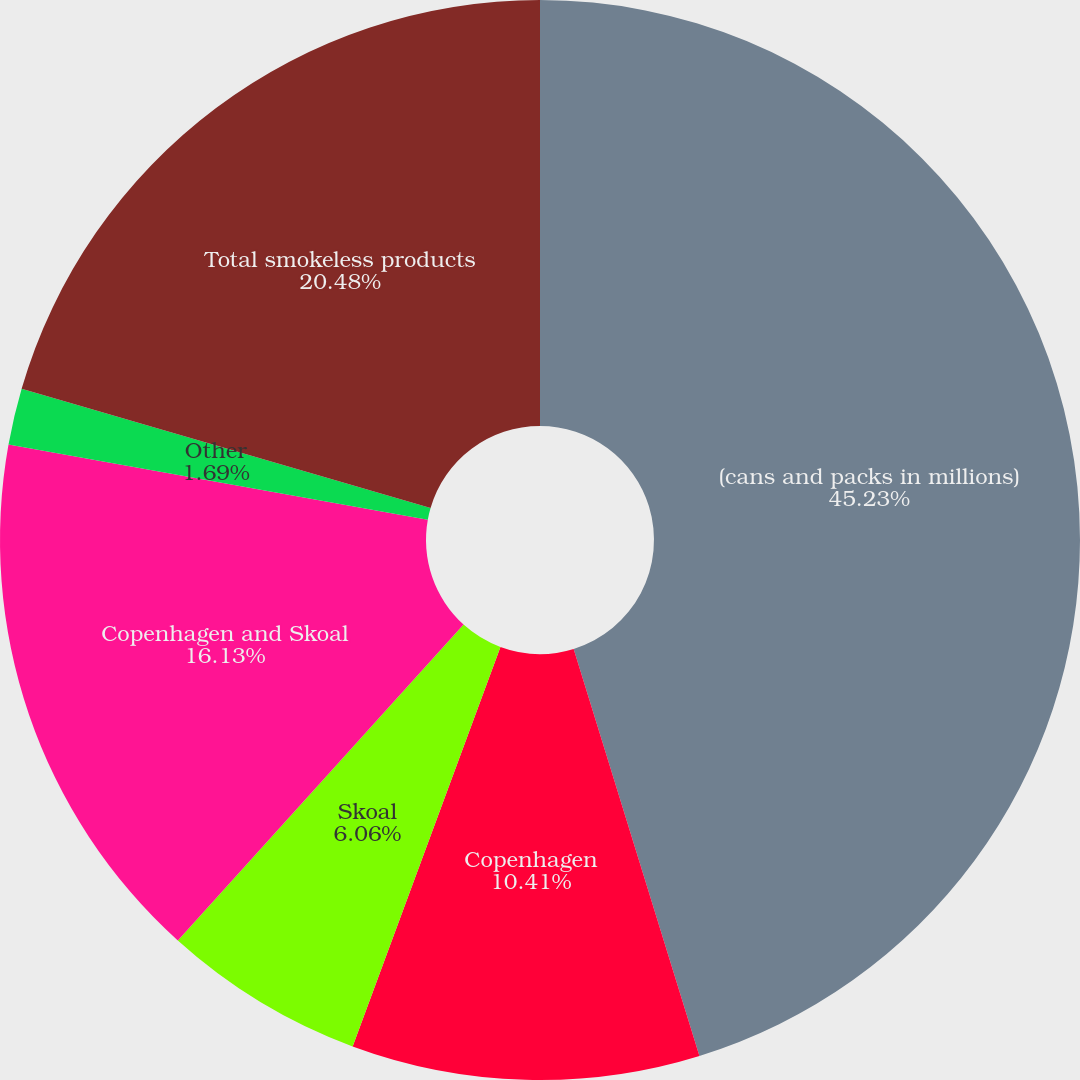Convert chart. <chart><loc_0><loc_0><loc_500><loc_500><pie_chart><fcel>(cans and packs in millions)<fcel>Copenhagen<fcel>Skoal<fcel>Copenhagen and Skoal<fcel>Other<fcel>Total smokeless products<nl><fcel>45.23%<fcel>10.41%<fcel>6.06%<fcel>16.13%<fcel>1.69%<fcel>20.48%<nl></chart> 